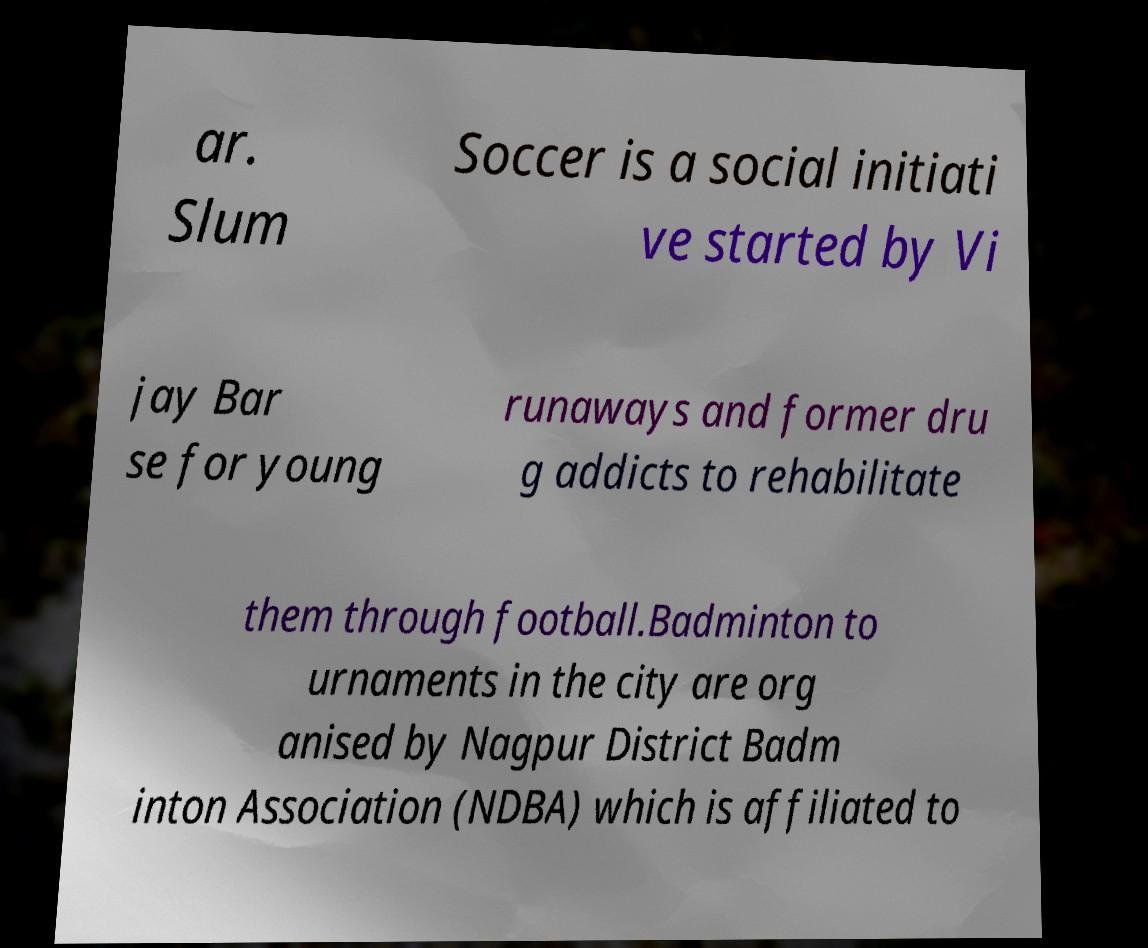Could you extract and type out the text from this image? ar. Slum Soccer is a social initiati ve started by Vi jay Bar se for young runaways and former dru g addicts to rehabilitate them through football.Badminton to urnaments in the city are org anised by Nagpur District Badm inton Association (NDBA) which is affiliated to 